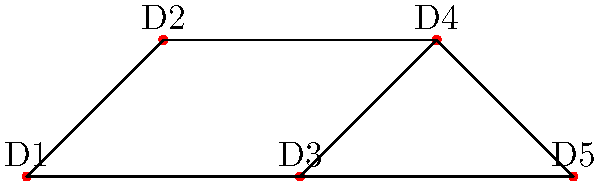In this network representing collaborations between silent film directors (D1 to D5), what is the minimum number of directors that need to be removed to disconnect D1 from D5? To solve this problem, we need to find the minimum number of vertex-disjoint paths between D1 and D5. This is equivalent to finding the vertex connectivity between these two nodes.

Step 1: Identify all possible paths from D1 to D5:
- Path 1: D1 - D2 - D4 - D5
- Path 2: D1 - D3 - D4 - D5
- Path 3: D1 - D3 - D5

Step 2: Determine the number of vertex-disjoint paths:
- Path 1 and Path 2 share vertex D4
- Path 1 and Path 3 are completely vertex-disjoint
- Path 2 and Path 3 share vertex D3

Therefore, there are 2 vertex-disjoint paths: (D1 - D2 - D4 - D5) and (D1 - D3 - D5)

Step 3: Apply Menger's theorem:
Menger's theorem states that the minimum number of vertices needed to disconnect two non-adjacent vertices is equal to the maximum number of vertex-disjoint paths between them.

Since we found 2 vertex-disjoint paths, the minimum number of directors that need to be removed to disconnect D1 from D5 is also 2.
Answer: 2 